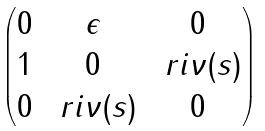<formula> <loc_0><loc_0><loc_500><loc_500>\begin{pmatrix} 0 & \epsilon & 0 \\ 1 & 0 & \ r i \nu ( s ) \\ 0 & \ r i \nu ( s ) & 0 \end{pmatrix}</formula> 